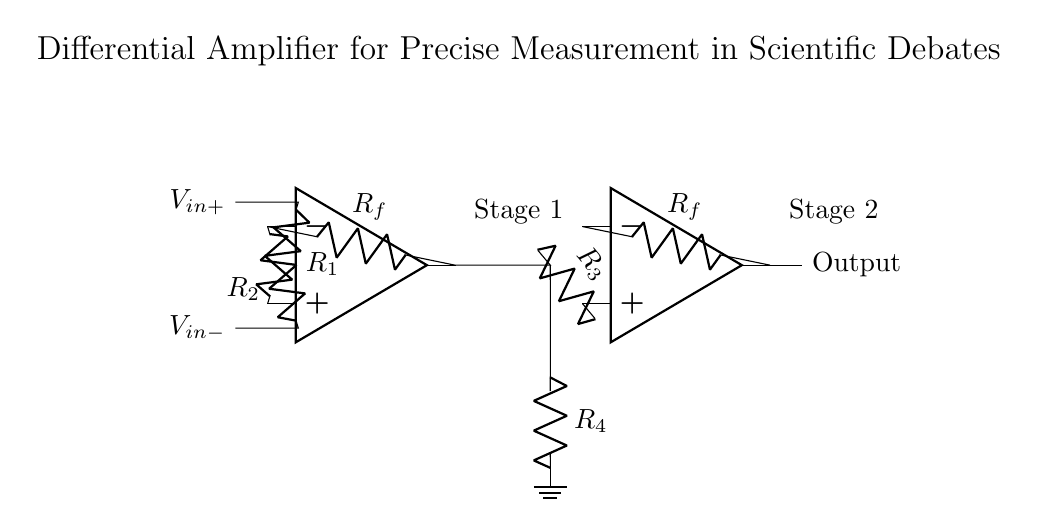What are the input voltages of this circuit? The input voltages labeled in the diagram are V in plus and V in minus. They are the signals that the differential amplifier is comparing.
Answer: V in plus, V in minus What is the purpose of the feedback resistors in this amplifier? The feedback resistors (R f) are used to set the gain of the amplifier, allowing for control of the output signal's amplification relative to the input signals.
Answer: Set gain How many operational amplifiers are present in this circuit? There are two operational amplifiers (op amps) in the diagram, clearly shown on the left and right sides of the circuit.
Answer: Two What is the function of resistor R 3 in this differential amplifier? Resistor R 3 connects the output of the first operational amplifier to the input of the second, helping to transfer the amplified signal while contributing to the overall system gain.
Answer: Transfer signal What determines the output voltage of this differential amplifier? The output voltage is determined by the difference between the input voltages (V in plus and V in minus) multiplied by the gains set by the resistors in the feedback paths.
Answer: Input voltage difference What type of amplifier is illustrated in this circuit? The circuit is a differential amplifier, which is specifically designed to amplify the difference between two voltages while rejecting signals that are common to both inputs.
Answer: Differential amplifier How does this circuit contribute to precise measurements in scientific debates? This circuit provides precise amplification of small differences in voltage, which is crucial for accurate measurements and analysis in scientific discussions.
Answer: Accurate measurements 